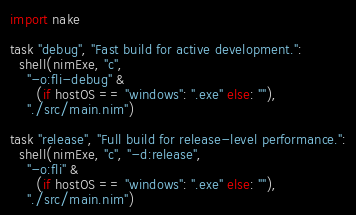<code> <loc_0><loc_0><loc_500><loc_500><_Nim_>import nake

task "debug", "Fast build for active development.":
  shell(nimExe, "c",
    "-o:fli-debug" &
      (if hostOS == "windows": ".exe" else: ""),
    "./src/main.nim")

task "release", "Full build for release-level performance.":
  shell(nimExe, "c", "-d:release",
    "-o:fli" &
      (if hostOS == "windows": ".exe" else: ""),
    "./src/main.nim")</code> 